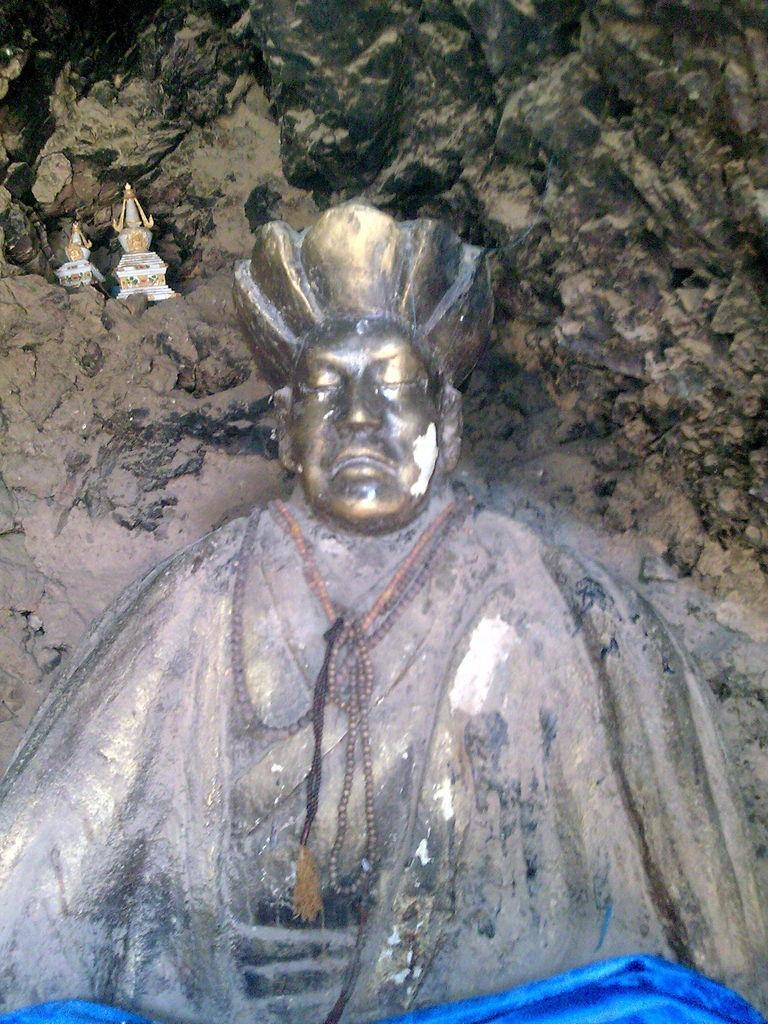What is the main subject in the image? There is a statue in the image. What can be seen in the background of the image? There is a rock in the background of the image. What other objects are present in the image besides the statue? There are idols in the image. How many dolls are participating in the competition in the image? There are no dolls or competitions present in the image. 